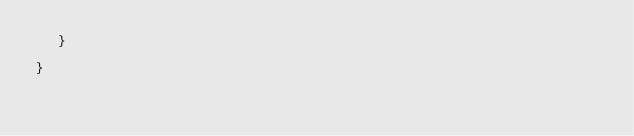<code> <loc_0><loc_0><loc_500><loc_500><_Java_>   }

}

</code> 